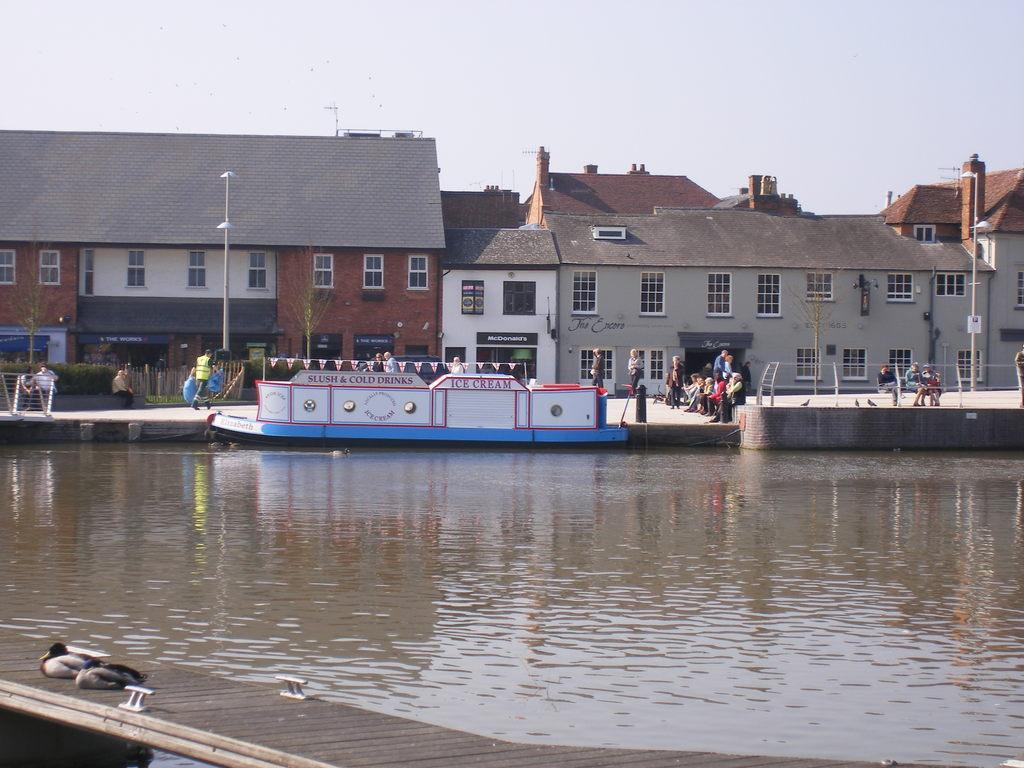How would you summarize this image in a sentence or two? In this picture I can see on the left side two ducks are sitting on the wooden plank. In the middle there is water and there is a shape in blue and white color. Few people are sitting on this thing and there are houses at the back side of an image. At the top it is the sky. 